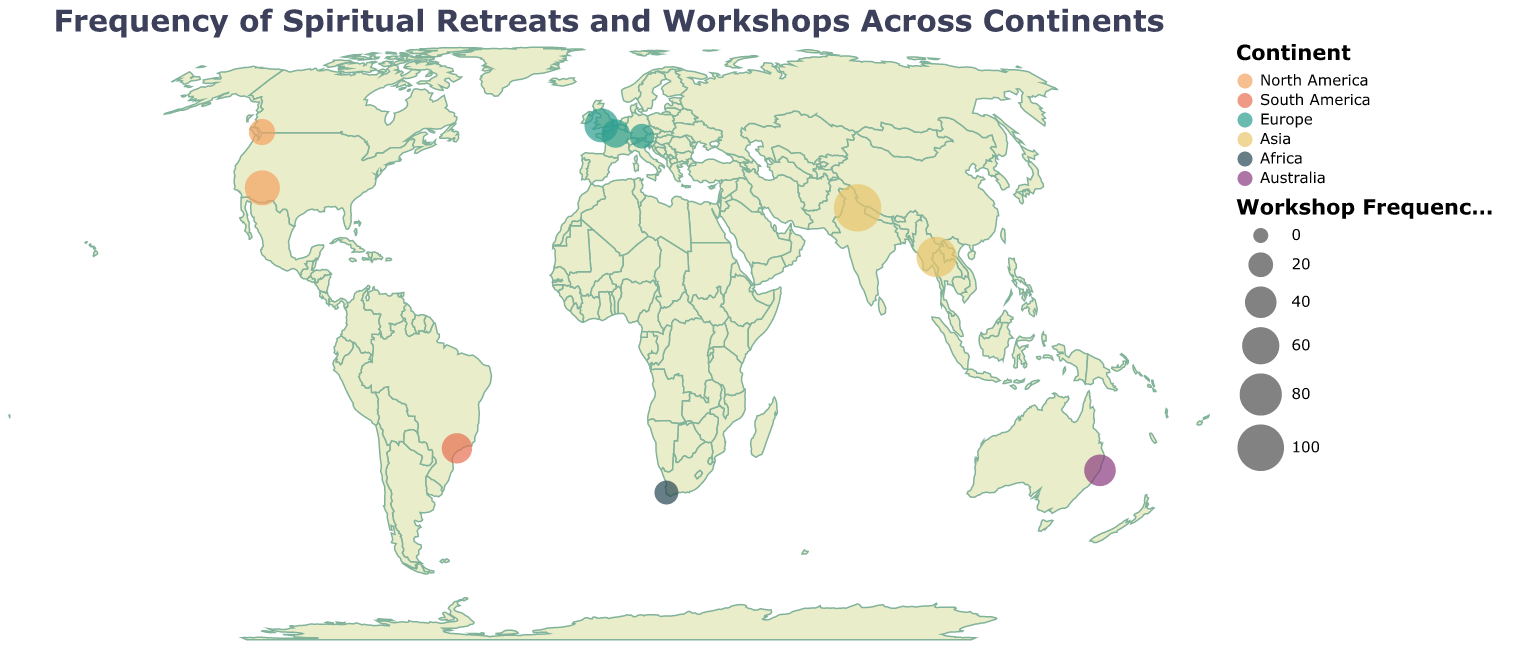What is the title of the plot? The title of the plot is located at the top and provides a summary of what the plot represents. This particular plot's title describes that it is about the frequency of spiritual retreats and workshops across continents.
Answer: Frequency of Spiritual Retreats and Workshops Across Continents Which city has the highest frequency of workshops? To determine which city has the highest frequency of workshops, look for the largest circle on the plot. The data associates frequency with the size of the circle, so the largest circle indicates the highest frequency.
Answer: Rishikesh How many cities in Europe are included in the plot? Look for the circles colored according to the European segment in the legend. Count each distinct city under this color category. According to the data provided, the European cities are Glastonbury, Paris, and Munich.
Answer: 3 Which continent has the most distinct cities represented? To find this, check the legend to identify each continent's color. Then, count the circles for each continent. Asia has cities Rishikesh and Chiang Mai with 2 cities, while North America also has 2 cities (Sedona and Vancouver). Other continents have fewer cities.
Answer: Asia and North America What is the combined frequency of workshops in South America and Africa? To find the combined frequency, look at the circles associated with Brazil (Sao Paulo) and South Africa (Cape Town). Add these frequencies together: 36 (Sao Paulo) + 18 (Cape Town) = 54.
Answer: 54 How does the frequency of workshops in Sedona compare to that in Glastonbury? Compare the sizes of the circles associated with Sedona and Glastonbury. Sedona has a frequency of 52, and Glastonbury has a frequency of 48.
Answer: Sedona has a higher frequency than Glastonbury Which continent has the city with the lowest frequency of workshops? Identify the circle with the smallest size looking at the numerical frequencies: Africa's Cape Town has a frequency of 18, which is the lowest among all the circles.
Answer: Africa What is the average frequency of workshops in Europe? Add the frequencies of the European cities (Glastonbury: 48, Paris: 30, Munich: 20) and then divide by the number of cities (3). The calculation is (48 + 30 + 20) / 3 = 32.67.
Answer: 32.67 Compare the frequency of workshops between Vancouver and Chiang Mai. Which one hosts more workshops and by how much? Look at the frequencies for Vancouver (24) and Chiang Mai (72). Subtract the smaller frequency from the larger one to find the difference: 72 - 24 = 48. Chiang Mai hosts 48 more workshops than Vancouver.
Answer: Chiang Mai, by 48 